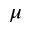<formula> <loc_0><loc_0><loc_500><loc_500>\mu</formula> 